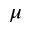<formula> <loc_0><loc_0><loc_500><loc_500>\mu</formula> 